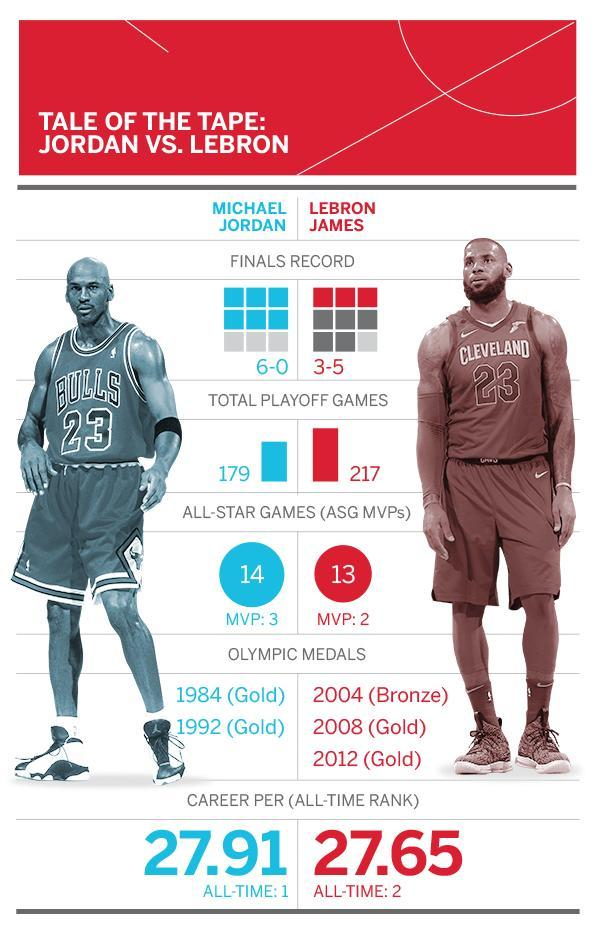When did Michael Jordan win gold in Olympics
Answer the question with a short phrase. 1984, 1992 WHo had a beard Lebron James What is written on the T shirt of Michael Jordan Bulls 23 What number is written on the T shirt of Lebron James 23 who is wearing a nike branded t shirt Lebron James When did Lebrom James win gold in Olympics 2008, 2012 